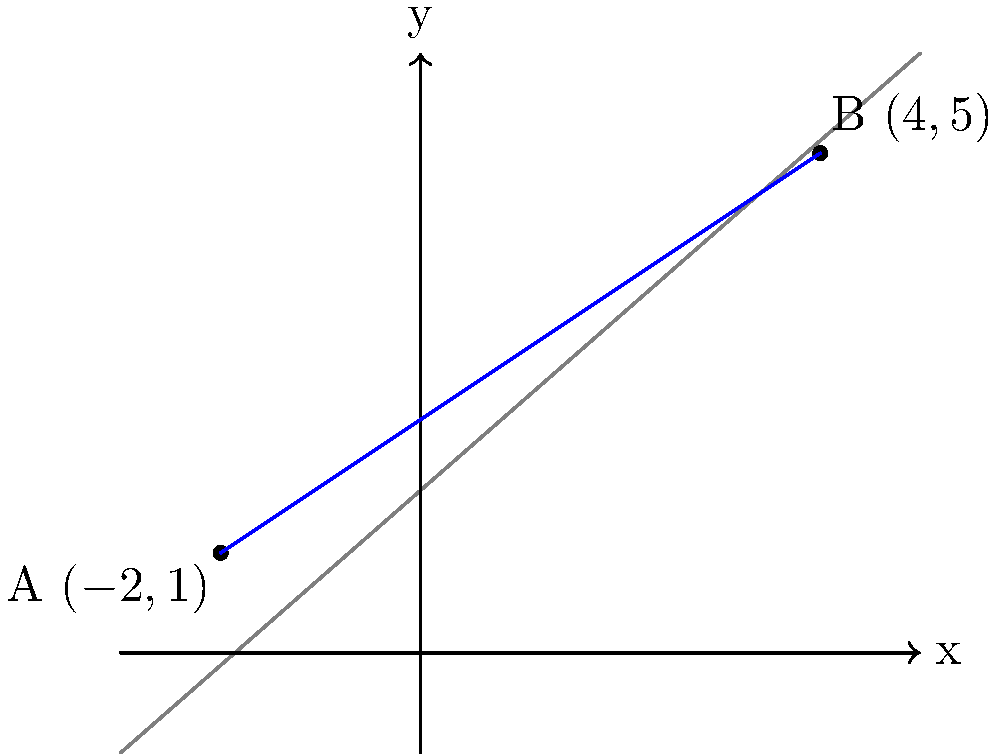Two crucial surveillance points have been identified on a coordinate grid. Point A is located at $(-2,1)$ and Point B at $(4,5)$. Calculate the exact distance between these two points to determine the minimum length of high-security cable required to connect them. Round your answer to three decimal places. To find the distance between two points, we use the distance formula derived from the Pythagorean theorem:

$d = \sqrt{(x_2-x_1)^2 + (y_2-y_1)^2}$

Where $(x_1,y_1)$ are the coordinates of the first point and $(x_2,y_2)$ are the coordinates of the second point.

Step 1: Identify the coordinates
Point A: $(-2,1)$, so $x_1 = -2$ and $y_1 = 1$
Point B: $(4,5)$, so $x_2 = 4$ and $y_2 = 5$

Step 2: Plug the values into the distance formula
$d = \sqrt{(4-(-2))^2 + (5-1)^2}$

Step 3: Simplify inside the parentheses
$d = \sqrt{(4+2)^2 + (4)^2}$
$d = \sqrt{6^2 + 4^2}$

Step 4: Calculate the squares
$d = \sqrt{36 + 16}$

Step 5: Add under the square root
$d = \sqrt{52}$

Step 6: Simplify the square root
$d = 2\sqrt{13}$

Step 7: Calculate and round to three decimal places
$d \approx 7.211$

Therefore, the exact distance between the two points is $2\sqrt{13}$ units, or approximately 7.211 units when rounded to three decimal places.
Answer: $2\sqrt{13}$ units (exact) or 7.211 units (rounded) 